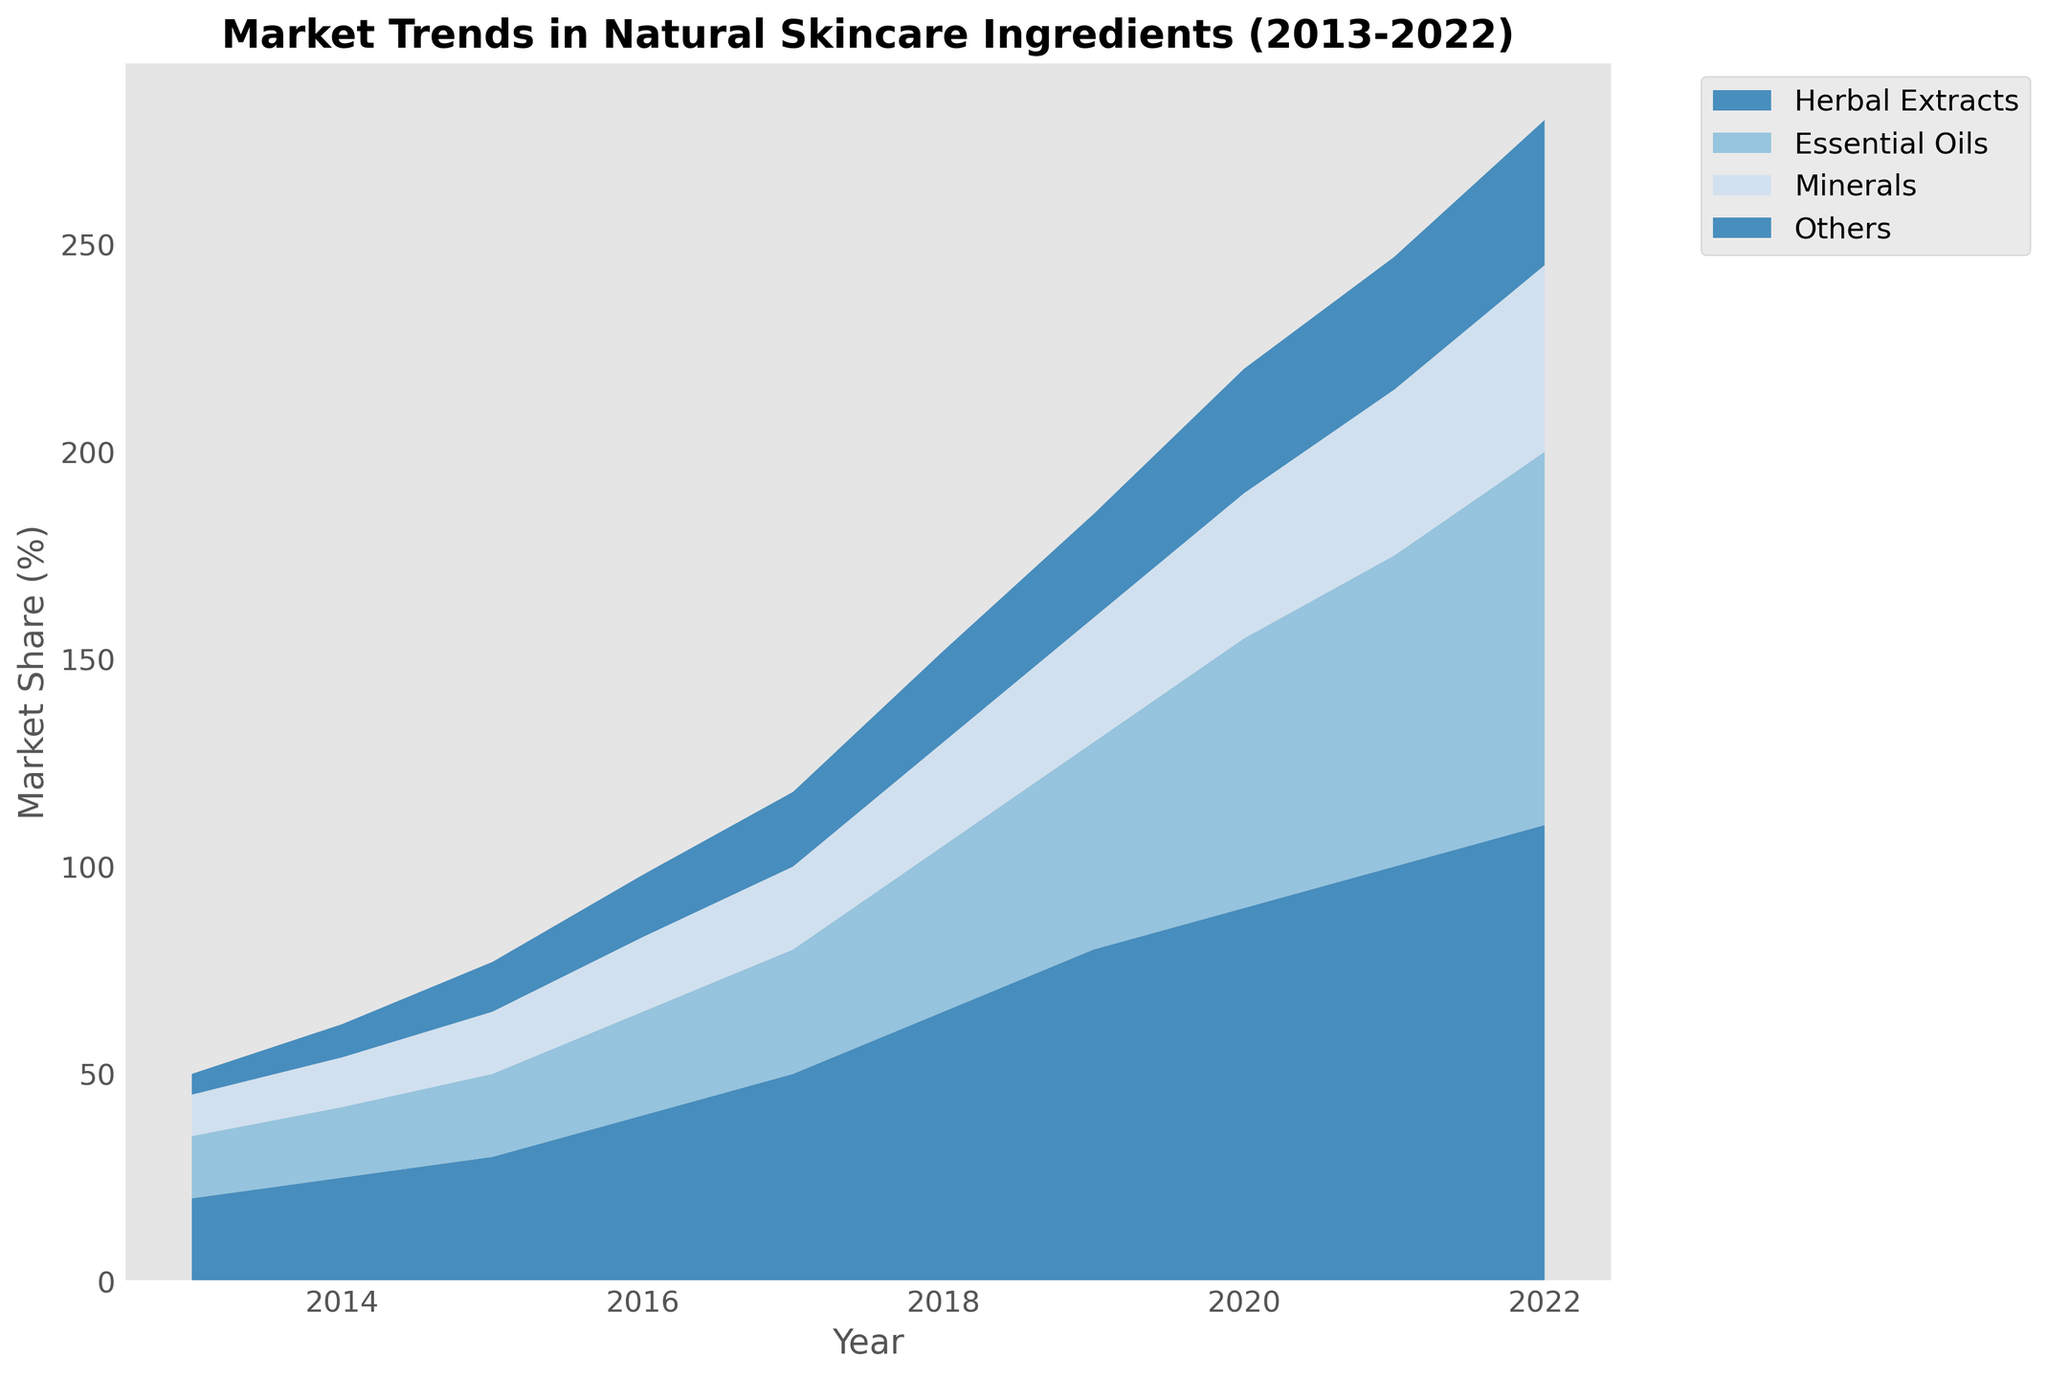What ingredient type saw the most consistent growth over the decade? By examining the area chart, look for the ingredient type with consistently rising market share from 2013 to 2022. Herbal Extracts demonstrate continuous and significant growth throughout the period, increasing from 20% to 110% market share.
Answer: Herbal Extracts Which ingredient type had the smallest market share in 2013? Observe the chart for the segment with the smallest area at the beginning of the timeline. The "Others" category shows the smallest market share in 2013 at 5%.
Answer: Others By how much did the market share of Essential Oils increase from 2013 to 2022? Find the difference between the market share of Essential Oils in 2022 and 2013. In 2013, Essential Oils had a 15% market share, increasing to 90% in 2022. The increase is 90 - 15 = 75%.
Answer: 75% In which year did Minerals reach a 25% market share? Check the chart for the year where Minerals’ market share hits 25%. This milestone occurs in 2018.
Answer: 2018 Which ingredient type had the highest market share in 2020? Examine the chart for the peak areas in 2020. Herbal Extracts had the highest market share in that year, at 90%.
Answer: Herbal Extracts What is the combined market share of all ingredient types in 2016? Add the market share percentages of all ingredient types in 2016: Herbal Extracts (40%), Essential Oils (25%), Minerals (18%), and Others (15%). The total is 40 + 25 + 18 + 15 = 98%.
Answer: 98% Between which two consecutive years did the market share of Herbal Extracts see the largest increase? Compare the year-on-year differences in Herbal Extracts market share. The largest increase occurs between 2017 and 2018, where it went from 50% to 65%, an increase of 15%.
Answer: 2017 and 2018 Which ingredient type had the highest rate of growth from 2017 to 2022? Calculate the rate of growth by looking at the relative increase for each ingredient type over this period. Herbal Extracts had the highest rate of growth, going from 50% to 110%, a 60% increase over five years.
Answer: Herbal Extracts In which year did Others surpass a 30% market share? Observe the chart to find the year when the "Others" section exceeds 30%. The "Others" category surpassed a 30% market share only in the year 2020.
Answer: 2020 How did the market share of Minerals change from 2015 to 2019? Identify the change in market share by subtracting the percentage in 2015 from that in 2019. Minerals had a 15% share in 2015, increasing to 30% in 2019. So, the increase is 30 - 15 = 15%.
Answer: 15% 